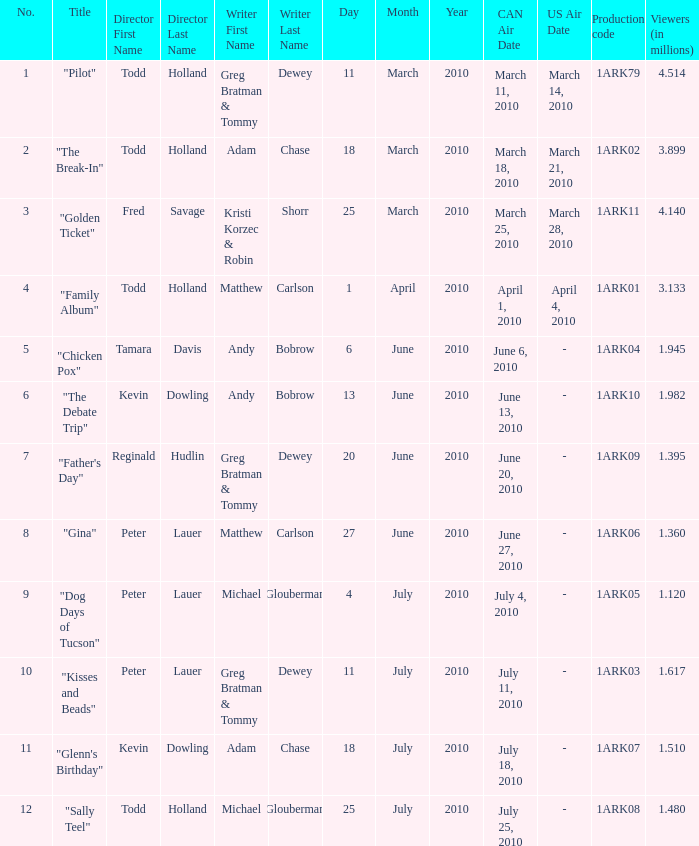List all who wrote for production code 1ark07. Adam Chase. 